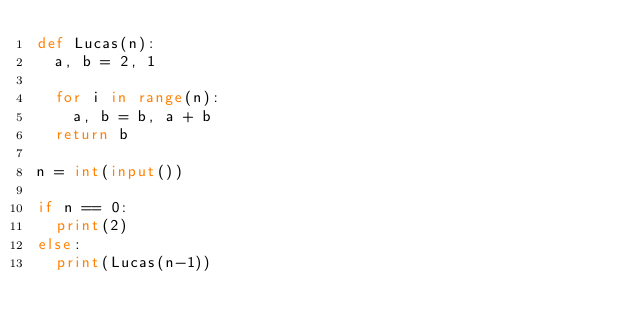Convert code to text. <code><loc_0><loc_0><loc_500><loc_500><_Python_>def Lucas(n):
	a, b = 2, 1
	
	for i in range(n):
		a, b = b, a + b
	return b
	
n = int(input())

if n == 0:
	print(2)
else:
	print(Lucas(n-1))
		
		</code> 